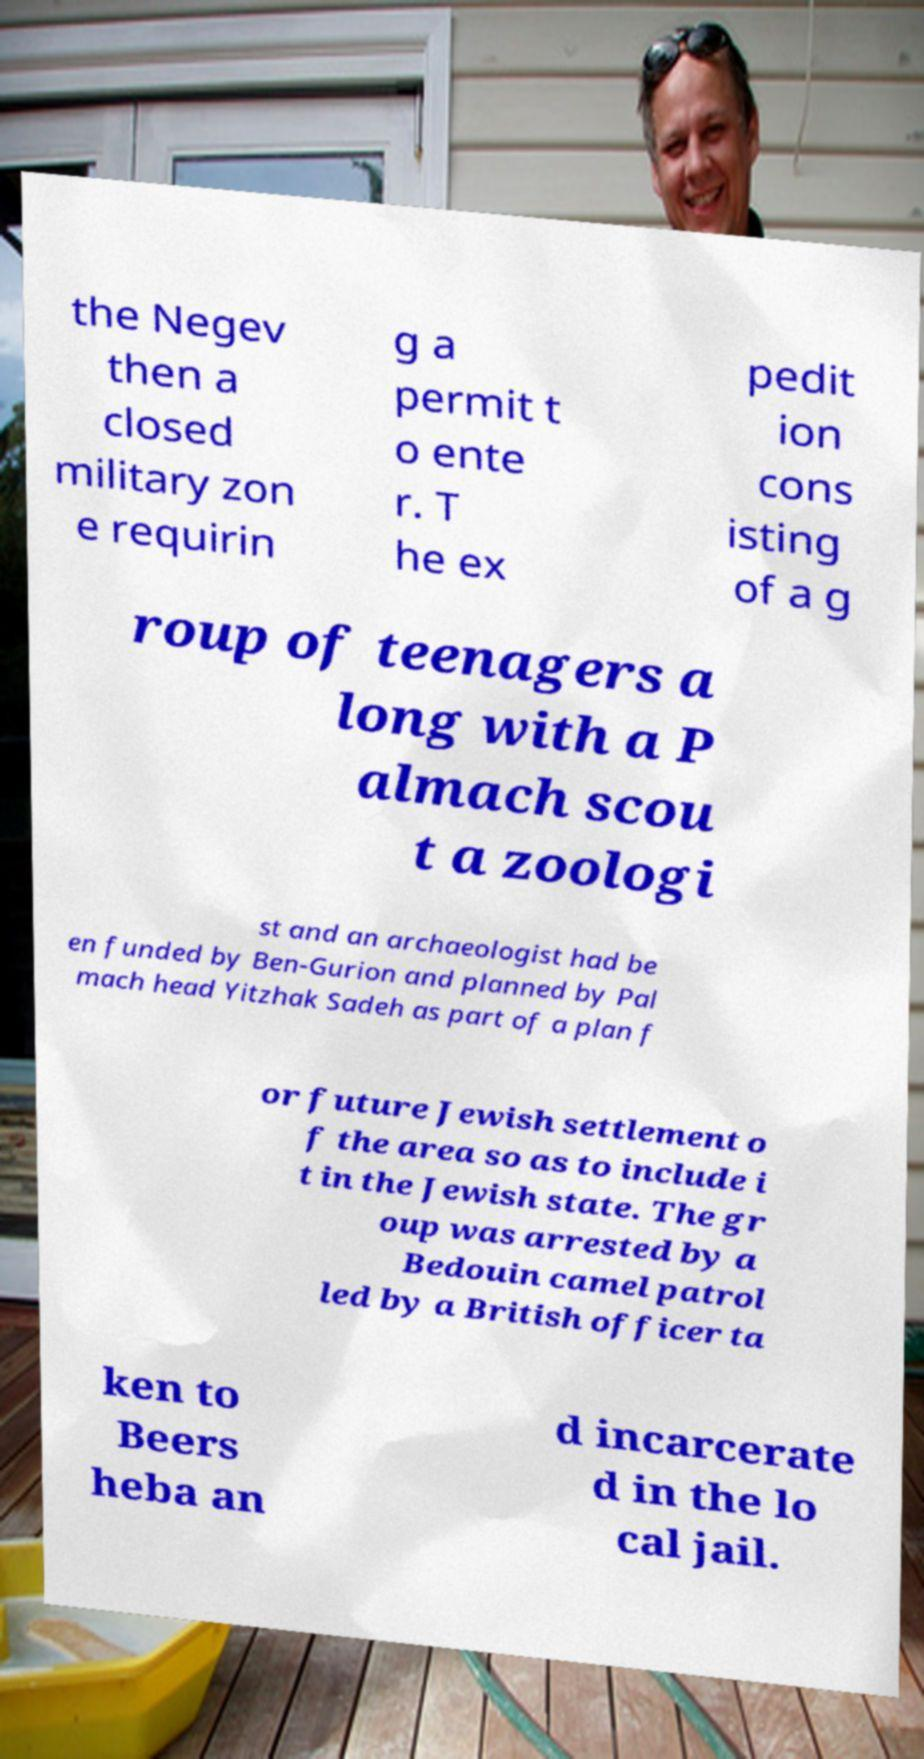What messages or text are displayed in this image? I need them in a readable, typed format. the Negev then a closed military zon e requirin g a permit t o ente r. T he ex pedit ion cons isting of a g roup of teenagers a long with a P almach scou t a zoologi st and an archaeologist had be en funded by Ben-Gurion and planned by Pal mach head Yitzhak Sadeh as part of a plan f or future Jewish settlement o f the area so as to include i t in the Jewish state. The gr oup was arrested by a Bedouin camel patrol led by a British officer ta ken to Beers heba an d incarcerate d in the lo cal jail. 